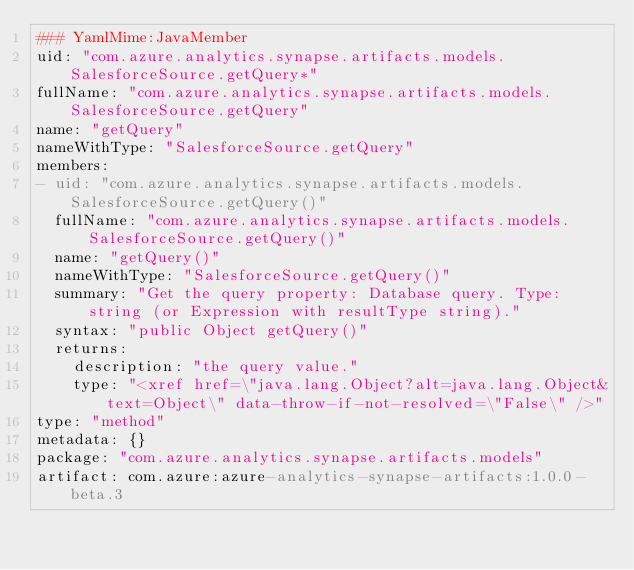Convert code to text. <code><loc_0><loc_0><loc_500><loc_500><_YAML_>### YamlMime:JavaMember
uid: "com.azure.analytics.synapse.artifacts.models.SalesforceSource.getQuery*"
fullName: "com.azure.analytics.synapse.artifacts.models.SalesforceSource.getQuery"
name: "getQuery"
nameWithType: "SalesforceSource.getQuery"
members:
- uid: "com.azure.analytics.synapse.artifacts.models.SalesforceSource.getQuery()"
  fullName: "com.azure.analytics.synapse.artifacts.models.SalesforceSource.getQuery()"
  name: "getQuery()"
  nameWithType: "SalesforceSource.getQuery()"
  summary: "Get the query property: Database query. Type: string (or Expression with resultType string)."
  syntax: "public Object getQuery()"
  returns:
    description: "the query value."
    type: "<xref href=\"java.lang.Object?alt=java.lang.Object&text=Object\" data-throw-if-not-resolved=\"False\" />"
type: "method"
metadata: {}
package: "com.azure.analytics.synapse.artifacts.models"
artifact: com.azure:azure-analytics-synapse-artifacts:1.0.0-beta.3
</code> 